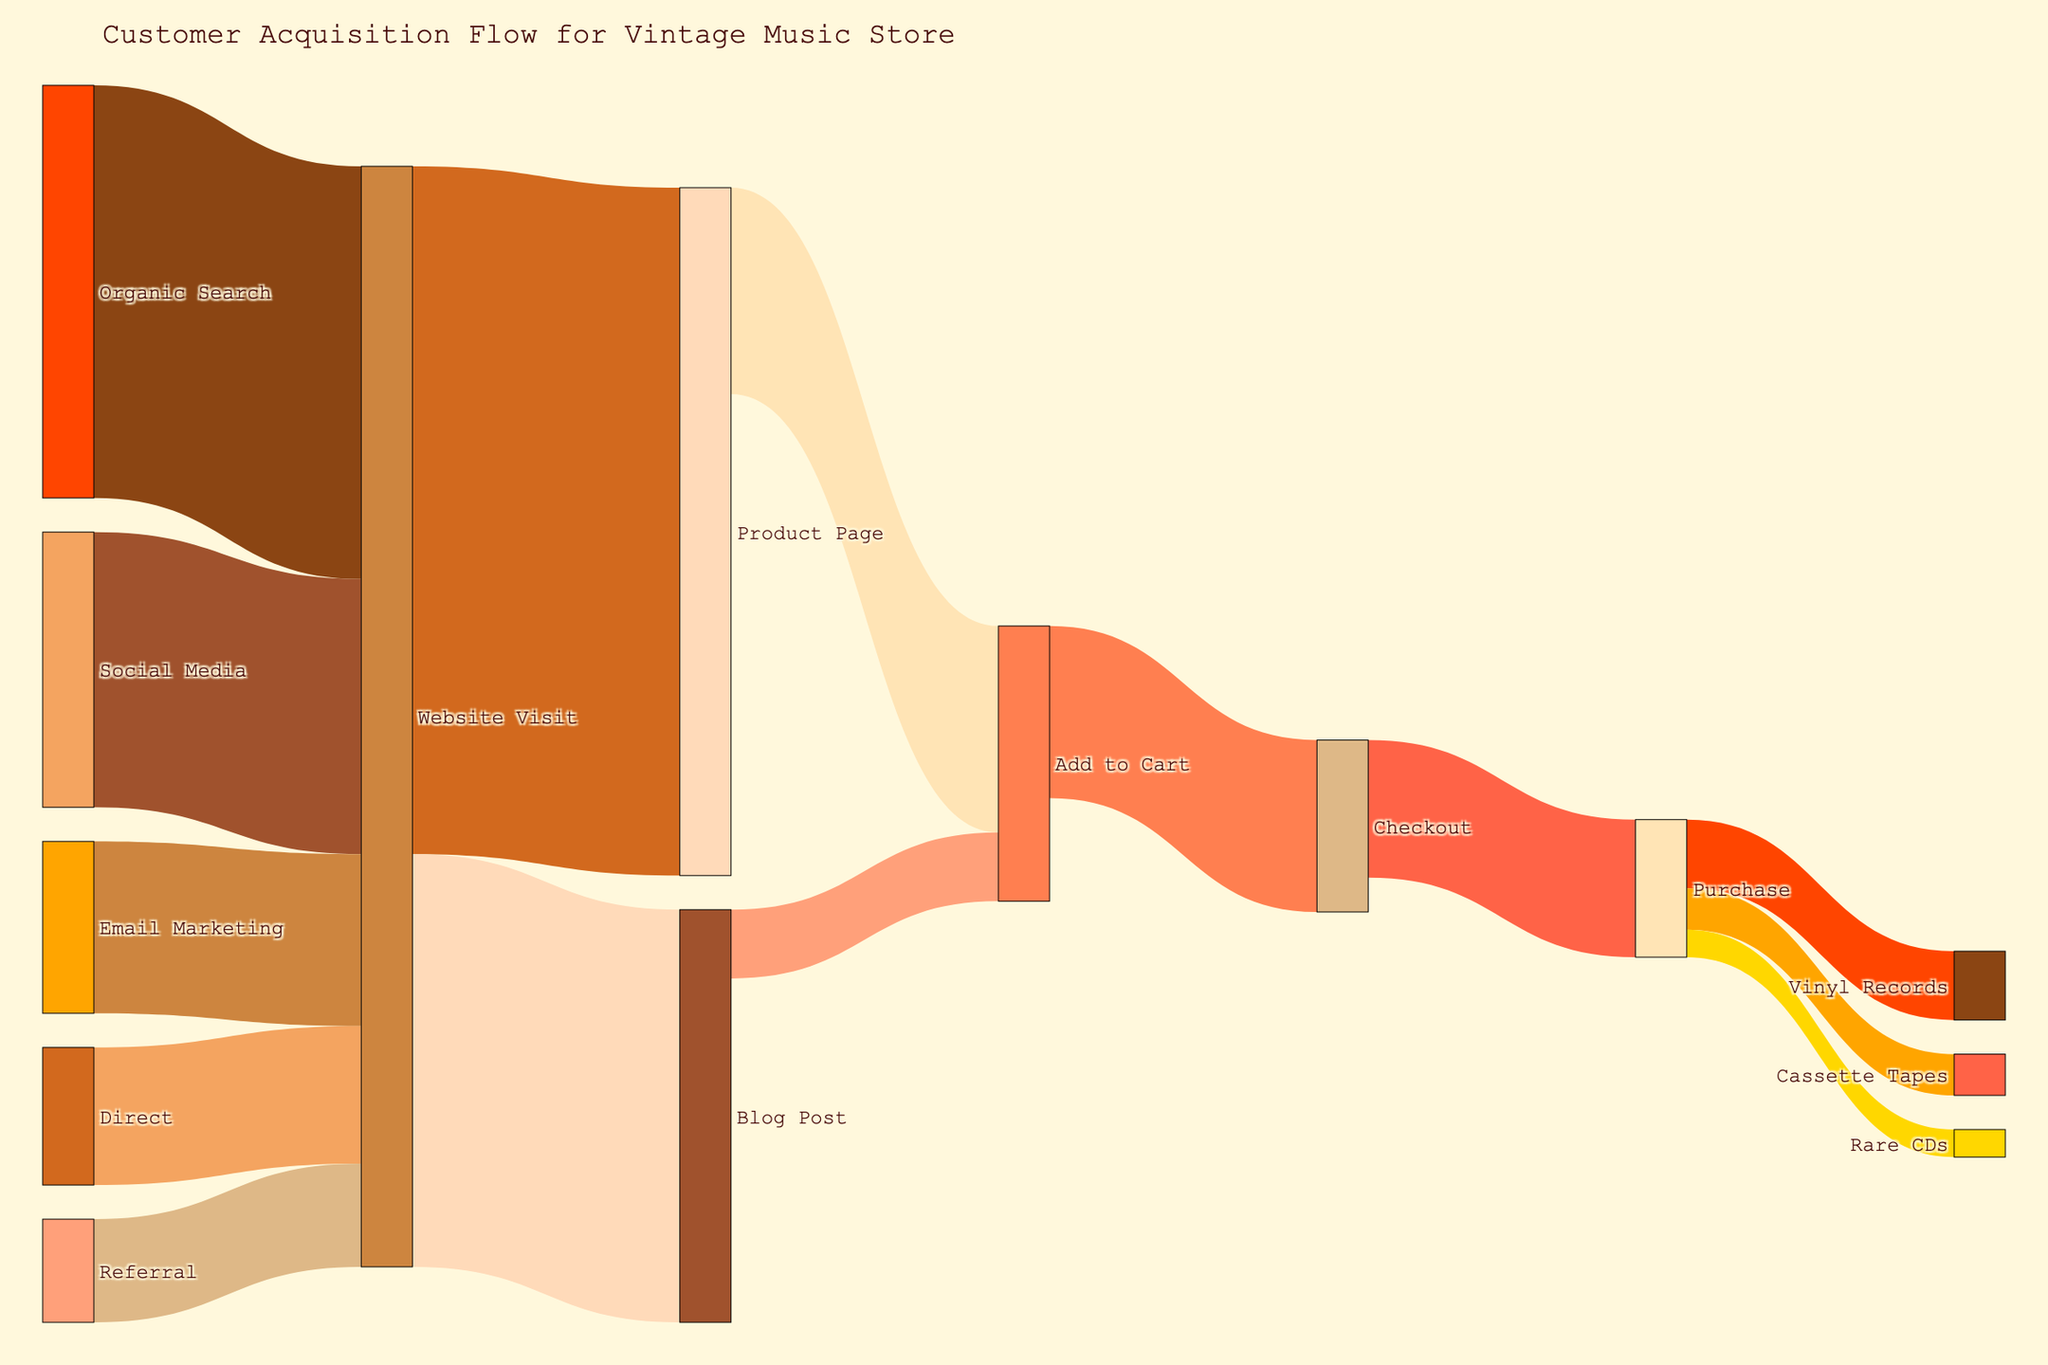What's the most common channel for website visits? The Sankey Diagram shows various customer acquisition channels leading to website visits. The width of the links represents the number of visits. By comparing the widths, it's clear that Organic Search contributes the most visits.
Answer: Organic Search Which channel contributes least to website visits? The diagram shows multiple channels connecting to website visits. The narrowest link represents the smallest contribution, which is from Referral.
Answer: Referral How many total website visits result in blog posts? To find this, follow the links originating from 'Website Visit' going towards 'Blog Post' and sum the value shown on the link. The value is 1200.
Answer: 1200 What is the conversion rate from 'Add to Cart' to 'Checkout'? To determine the conversion rate, divide the value at Checkout by the value at Add to Cart. This is 500/800.
Answer: 62.5% How many customers ultimately purchase Rare CDs? Follow the flow from 'Purchase' to 'Rare CDs' and check the value, which is 80.
Answer: 80 Which product category has the highest purchase rate? By examining the flow from 'Purchase' to each product category, the width of the links shows that Vinyl Records has the highest value at 200.
Answer: Vinyl Records Compare the number of customers reading blog posts to those adding products to the cart from the blog. From the diagram, Blog Post has 1200 visits and 200 of them add to the cart. Subtracting these gives the remaining customers who read the posts but didn’t add to the cart: 1200 - 200 = 1000.
Answer: 1000 What's the total number of customers progressing past 'Website Visit'? Summing up the values that leave 'Website Visit' towards 'Product Page' (2000) and 'Blog Post' (1200) gives the total: 2000 + 1200 = 3200.
Answer: 3200 What percentage of customers adds a product to the cart after visiting the product page? The conversion rate is found by dividing the value at 'Add to Cart' from 'Product Page' by the total 'Product Page' visits: 600/2000 = 30%.
Answer: 30% What's the most frequent next step after a 'Website Visit'? Comparing the values leading from 'Website Visit,' the widest link goes to 'Product Page' which indicates it's the most frequent next step.
Answer: Product Page 